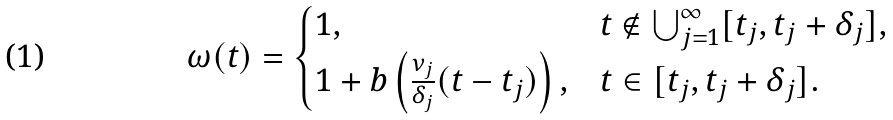<formula> <loc_0><loc_0><loc_500><loc_500>\omega ( t ) = \begin{cases} 1 , & t \not \in \bigcup _ { j = 1 } ^ { \infty } [ t _ { j } , t _ { j } + \delta _ { j } ] , \\ 1 + b \left ( \frac { \nu _ { j } } { \delta _ { j } } ( t - t _ { j } ) \right ) , & t \in [ t _ { j } , t _ { j } + \delta _ { j } ] . \end{cases}</formula> 